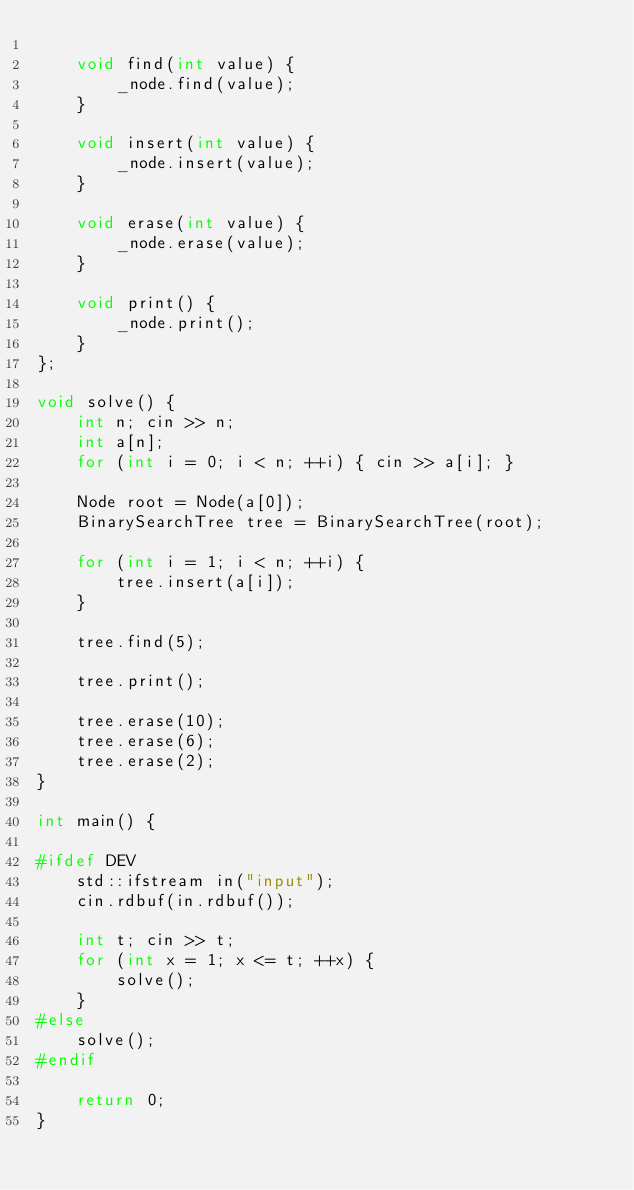<code> <loc_0><loc_0><loc_500><loc_500><_C++_>
    void find(int value) {
        _node.find(value);
    }

    void insert(int value) {
        _node.insert(value);
    }

    void erase(int value) {
        _node.erase(value);
    }

    void print() {
        _node.print();
    }
};

void solve() {
    int n; cin >> n;
    int a[n];
    for (int i = 0; i < n; ++i) { cin >> a[i]; }

    Node root = Node(a[0]);
    BinarySearchTree tree = BinarySearchTree(root);

    for (int i = 1; i < n; ++i) {
        tree.insert(a[i]);
    }

    tree.find(5);

    tree.print();

    tree.erase(10);
    tree.erase(6);
    tree.erase(2);
}

int main() {

#ifdef DEV
    std::ifstream in("input");
    cin.rdbuf(in.rdbuf());

    int t; cin >> t;
    for (int x = 1; x <= t; ++x) {
        solve();
    }
#else
    solve();
#endif

    return 0;
}
</code> 